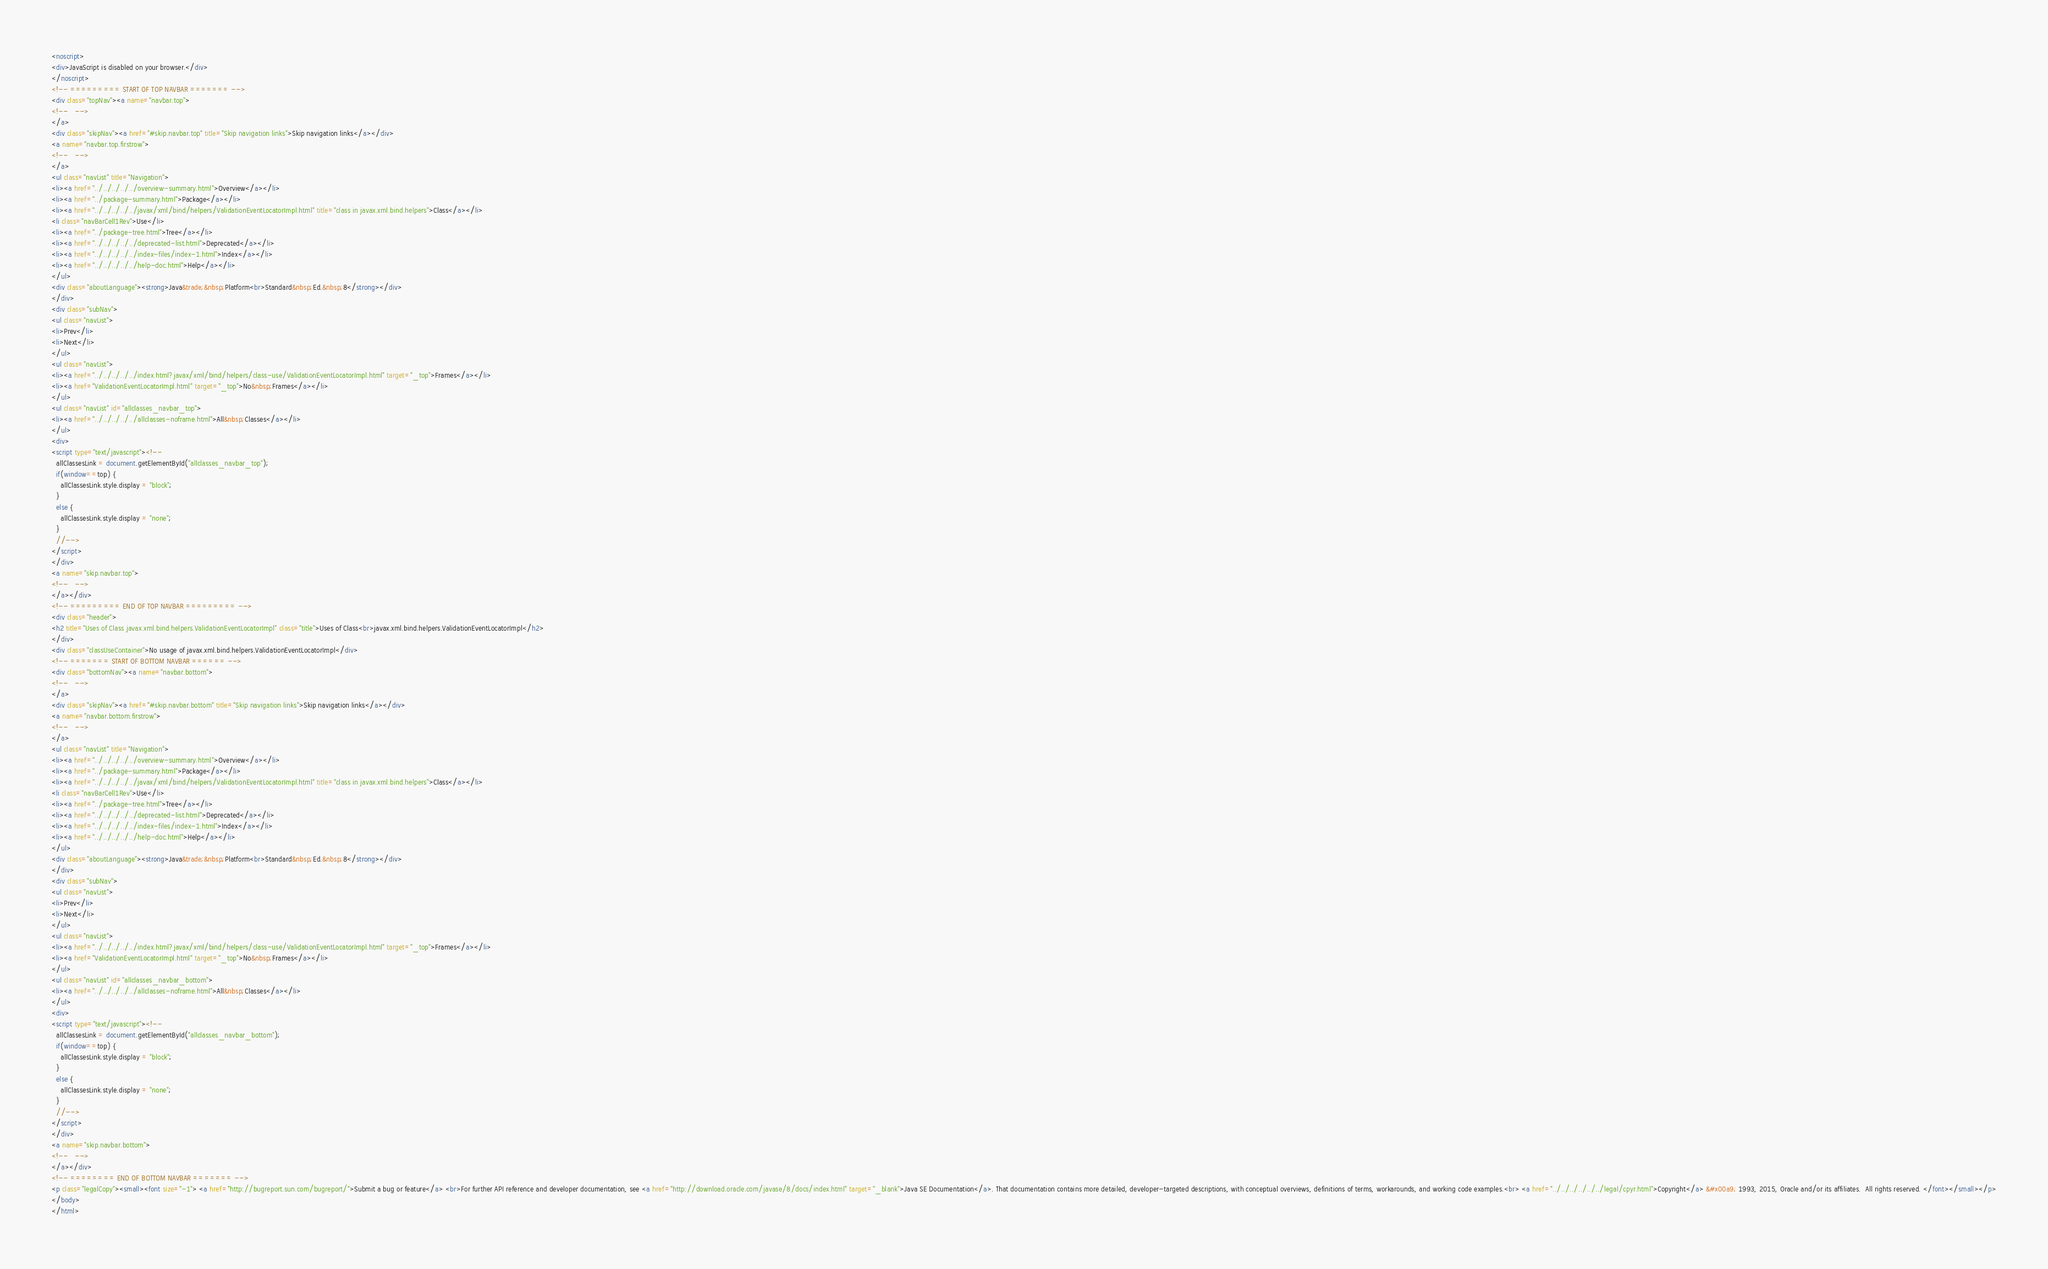Convert code to text. <code><loc_0><loc_0><loc_500><loc_500><_HTML_><noscript>
<div>JavaScript is disabled on your browser.</div>
</noscript>
<!-- ========= START OF TOP NAVBAR ======= -->
<div class="topNav"><a name="navbar.top">
<!--   -->
</a>
<div class="skipNav"><a href="#skip.navbar.top" title="Skip navigation links">Skip navigation links</a></div>
<a name="navbar.top.firstrow">
<!--   -->
</a>
<ul class="navList" title="Navigation">
<li><a href="../../../../../overview-summary.html">Overview</a></li>
<li><a href="../package-summary.html">Package</a></li>
<li><a href="../../../../../javax/xml/bind/helpers/ValidationEventLocatorImpl.html" title="class in javax.xml.bind.helpers">Class</a></li>
<li class="navBarCell1Rev">Use</li>
<li><a href="../package-tree.html">Tree</a></li>
<li><a href="../../../../../deprecated-list.html">Deprecated</a></li>
<li><a href="../../../../../index-files/index-1.html">Index</a></li>
<li><a href="../../../../../help-doc.html">Help</a></li>
</ul>
<div class="aboutLanguage"><strong>Java&trade;&nbsp;Platform<br>Standard&nbsp;Ed.&nbsp;8</strong></div>
</div>
<div class="subNav">
<ul class="navList">
<li>Prev</li>
<li>Next</li>
</ul>
<ul class="navList">
<li><a href="../../../../../index.html?javax/xml/bind/helpers/class-use/ValidationEventLocatorImpl.html" target="_top">Frames</a></li>
<li><a href="ValidationEventLocatorImpl.html" target="_top">No&nbsp;Frames</a></li>
</ul>
<ul class="navList" id="allclasses_navbar_top">
<li><a href="../../../../../allclasses-noframe.html">All&nbsp;Classes</a></li>
</ul>
<div>
<script type="text/javascript"><!--
  allClassesLink = document.getElementById("allclasses_navbar_top");
  if(window==top) {
    allClassesLink.style.display = "block";
  }
  else {
    allClassesLink.style.display = "none";
  }
  //-->
</script>
</div>
<a name="skip.navbar.top">
<!--   -->
</a></div>
<!-- ========= END OF TOP NAVBAR ========= -->
<div class="header">
<h2 title="Uses of Class javax.xml.bind.helpers.ValidationEventLocatorImpl" class="title">Uses of Class<br>javax.xml.bind.helpers.ValidationEventLocatorImpl</h2>
</div>
<div class="classUseContainer">No usage of javax.xml.bind.helpers.ValidationEventLocatorImpl</div>
<!-- ======= START OF BOTTOM NAVBAR ====== -->
<div class="bottomNav"><a name="navbar.bottom">
<!--   -->
</a>
<div class="skipNav"><a href="#skip.navbar.bottom" title="Skip navigation links">Skip navigation links</a></div>
<a name="navbar.bottom.firstrow">
<!--   -->
</a>
<ul class="navList" title="Navigation">
<li><a href="../../../../../overview-summary.html">Overview</a></li>
<li><a href="../package-summary.html">Package</a></li>
<li><a href="../../../../../javax/xml/bind/helpers/ValidationEventLocatorImpl.html" title="class in javax.xml.bind.helpers">Class</a></li>
<li class="navBarCell1Rev">Use</li>
<li><a href="../package-tree.html">Tree</a></li>
<li><a href="../../../../../deprecated-list.html">Deprecated</a></li>
<li><a href="../../../../../index-files/index-1.html">Index</a></li>
<li><a href="../../../../../help-doc.html">Help</a></li>
</ul>
<div class="aboutLanguage"><strong>Java&trade;&nbsp;Platform<br>Standard&nbsp;Ed.&nbsp;8</strong></div>
</div>
<div class="subNav">
<ul class="navList">
<li>Prev</li>
<li>Next</li>
</ul>
<ul class="navList">
<li><a href="../../../../../index.html?javax/xml/bind/helpers/class-use/ValidationEventLocatorImpl.html" target="_top">Frames</a></li>
<li><a href="ValidationEventLocatorImpl.html" target="_top">No&nbsp;Frames</a></li>
</ul>
<ul class="navList" id="allclasses_navbar_bottom">
<li><a href="../../../../../allclasses-noframe.html">All&nbsp;Classes</a></li>
</ul>
<div>
<script type="text/javascript"><!--
  allClassesLink = document.getElementById("allclasses_navbar_bottom");
  if(window==top) {
    allClassesLink.style.display = "block";
  }
  else {
    allClassesLink.style.display = "none";
  }
  //-->
</script>
</div>
<a name="skip.navbar.bottom">
<!--   -->
</a></div>
<!-- ======== END OF BOTTOM NAVBAR ======= -->
<p class="legalCopy"><small><font size="-1"> <a href="http://bugreport.sun.com/bugreport/">Submit a bug or feature</a> <br>For further API reference and developer documentation, see <a href="http://download.oracle.com/javase/8/docs/index.html" target="_blank">Java SE Documentation</a>. That documentation contains more detailed, developer-targeted descriptions, with conceptual overviews, definitions of terms, workarounds, and working code examples.<br> <a href="../../../../../../legal/cpyr.html">Copyright</a> &#x00a9; 1993, 2015, Oracle and/or its affiliates.  All rights reserved. </font></small></p>
</body>
</html>
</code> 